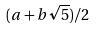Convert formula to latex. <formula><loc_0><loc_0><loc_500><loc_500>( a + b \sqrt { 5 } ) / 2</formula> 